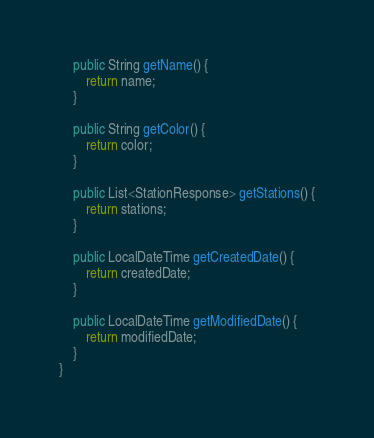Convert code to text. <code><loc_0><loc_0><loc_500><loc_500><_Java_>
    public String getName() {
        return name;
    }

    public String getColor() {
        return color;
    }

    public List<StationResponse> getStations() {
        return stations;
    }

    public LocalDateTime getCreatedDate() {
        return createdDate;
    }

    public LocalDateTime getModifiedDate() {
        return modifiedDate;
    }
}
</code> 